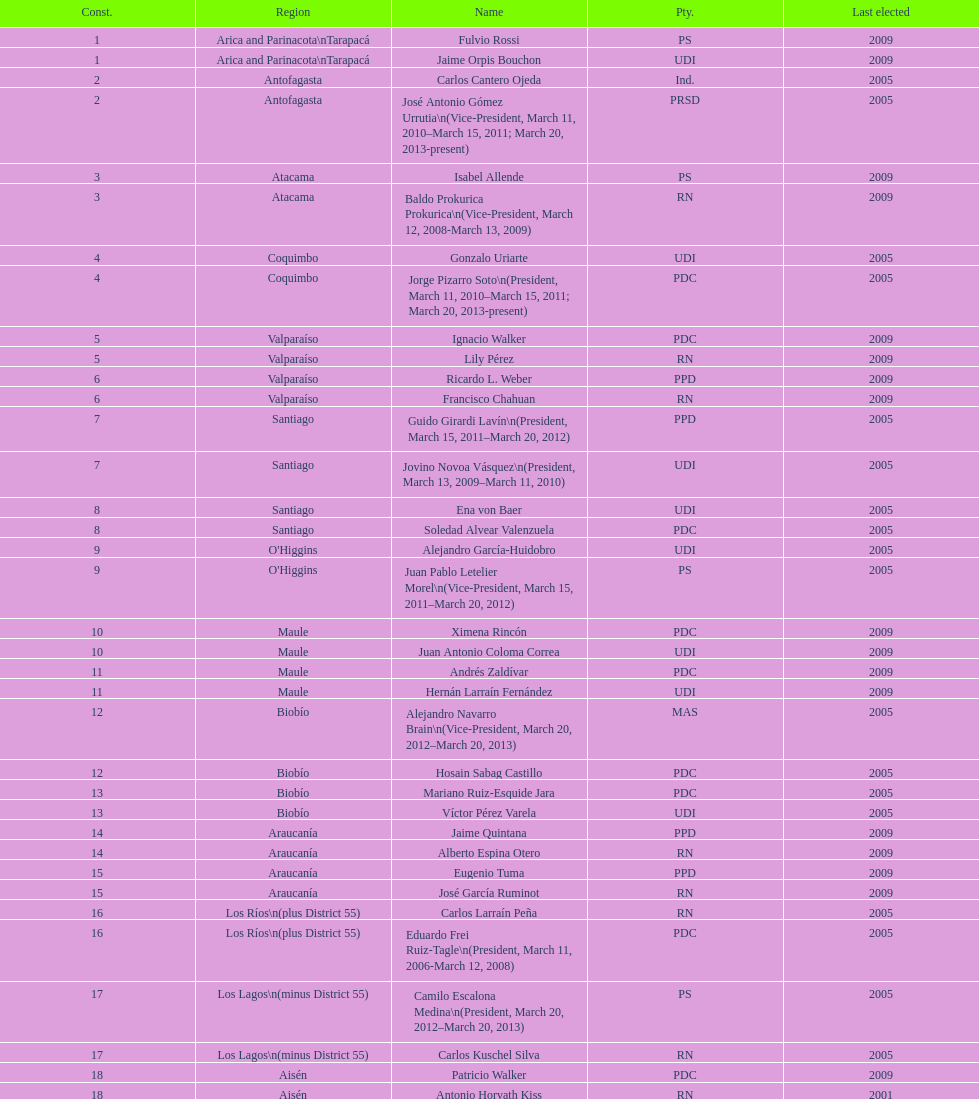Who didn't have their most recent election win in 2005 or 2009? Antonio Horvath Kiss. 